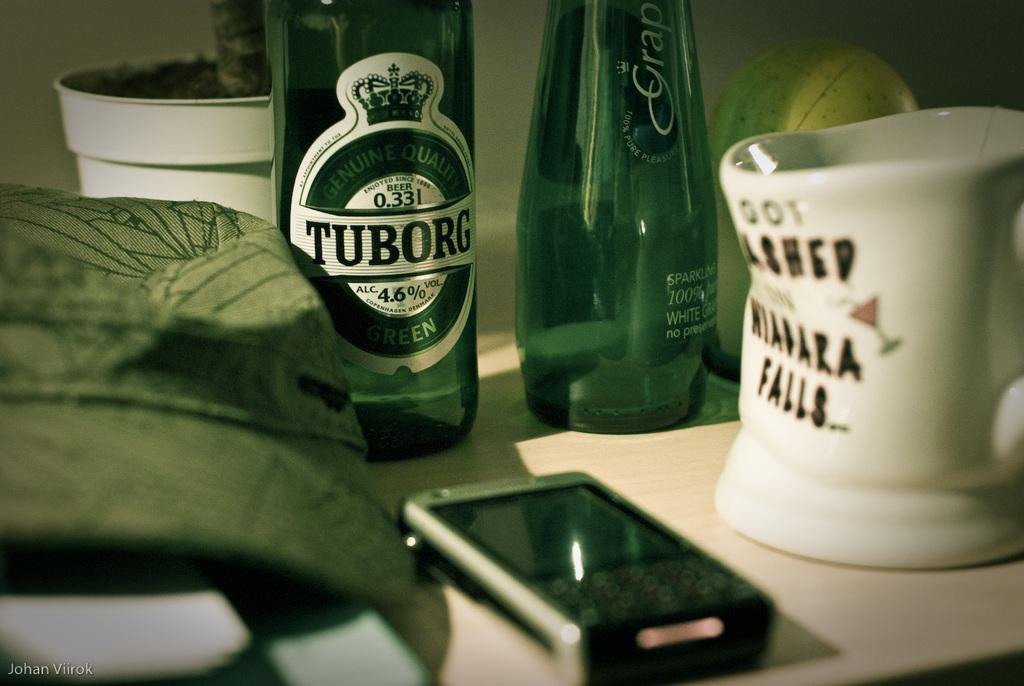<image>
Summarize the visual content of the image. A glass of Tuborg and a mug on a desk. 